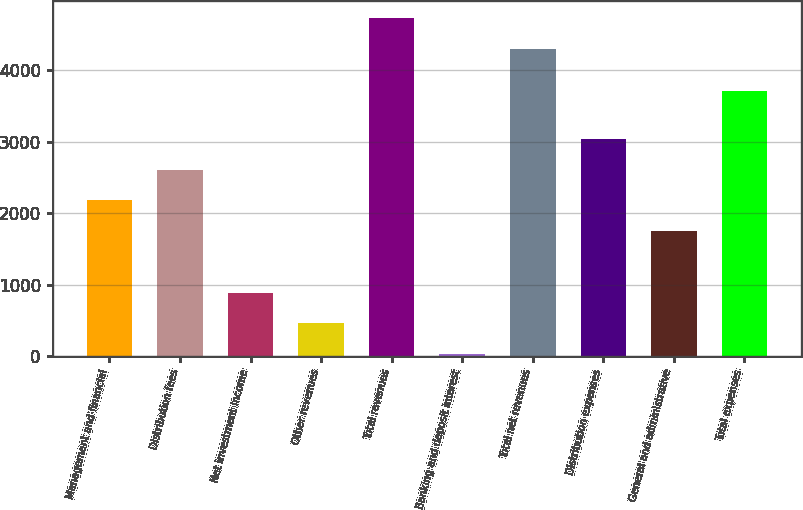Convert chart. <chart><loc_0><loc_0><loc_500><loc_500><bar_chart><fcel>Management and financial<fcel>Distribution fees<fcel>Net investment income<fcel>Other revenues<fcel>Total revenues<fcel>Banking and deposit interest<fcel>Total net revenues<fcel>Distribution expenses<fcel>General and administrative<fcel>Total expenses<nl><fcel>2178.5<fcel>2608<fcel>890<fcel>460.5<fcel>4724.5<fcel>31<fcel>4295<fcel>3037.5<fcel>1749<fcel>3703<nl></chart> 